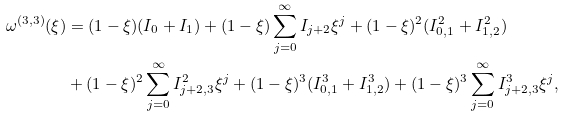Convert formula to latex. <formula><loc_0><loc_0><loc_500><loc_500>\omega ^ { ( 3 , 3 ) } ( \xi ) & = ( 1 - \xi ) ( I _ { 0 } + I _ { 1 } ) + ( 1 - \xi ) \sum _ { j = 0 } ^ { \infty } I _ { j + 2 } \xi ^ { j } + ( 1 - \xi ) ^ { 2 } ( I _ { 0 , 1 } ^ { 2 } + I _ { 1 , 2 } ^ { 2 } ) \\ & + ( 1 - \xi ) ^ { 2 } \sum _ { j = 0 } ^ { \infty } I _ { j + 2 , 3 } ^ { 2 } \xi ^ { j } + ( 1 - \xi ) ^ { 3 } ( I _ { 0 , 1 } ^ { 3 } + I _ { 1 , 2 } ^ { 3 } ) + ( 1 - \xi ) ^ { 3 } \sum _ { j = 0 } ^ { \infty } I _ { j + 2 , 3 } ^ { 3 } \xi ^ { j } ,</formula> 